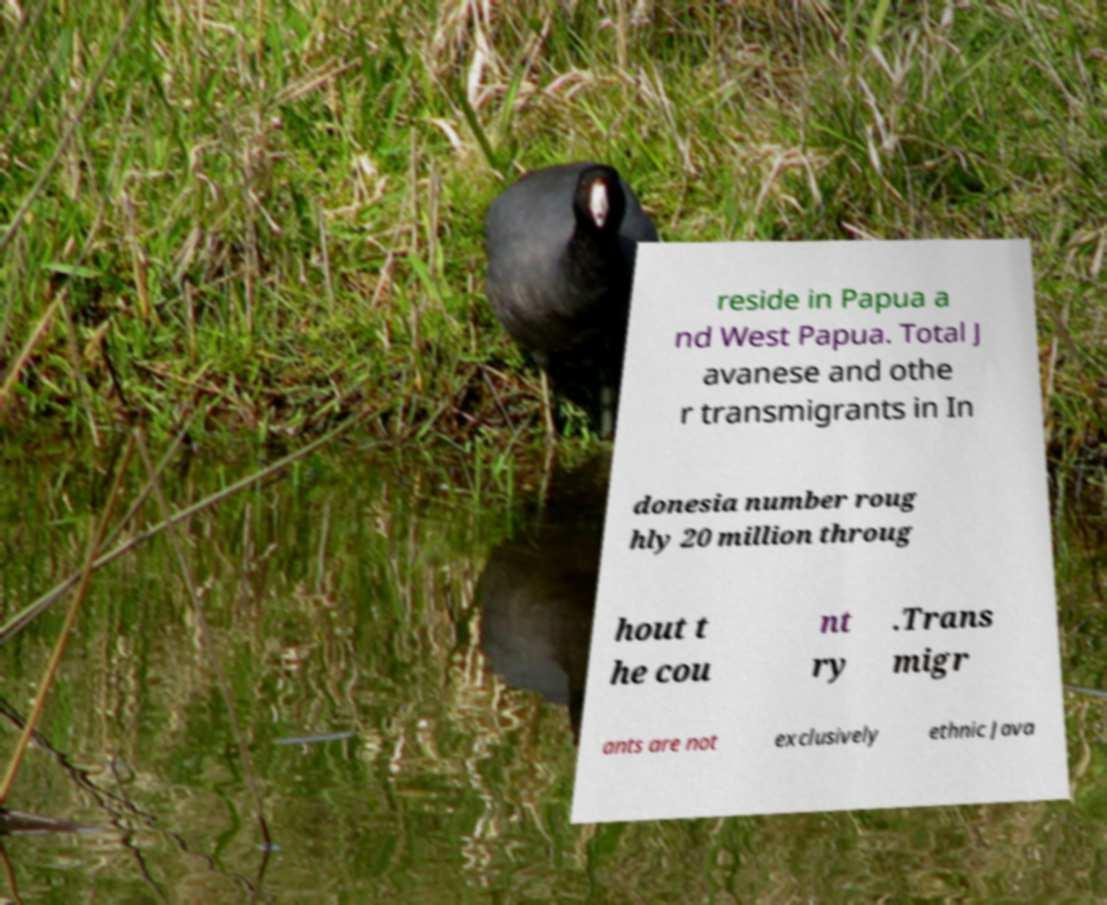What messages or text are displayed in this image? I need them in a readable, typed format. reside in Papua a nd West Papua. Total J avanese and othe r transmigrants in In donesia number roug hly 20 million throug hout t he cou nt ry .Trans migr ants are not exclusively ethnic Java 